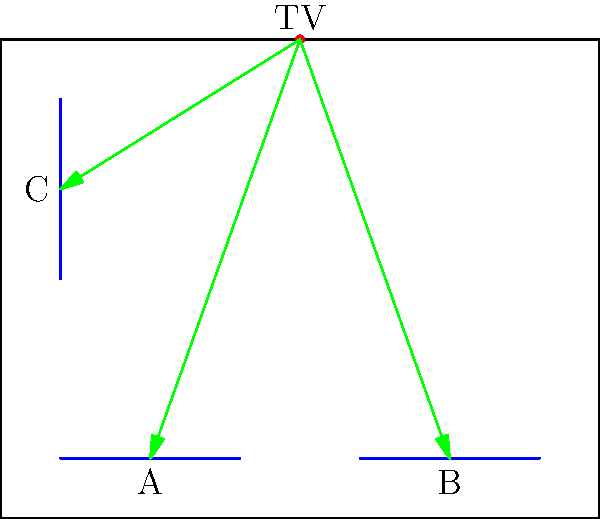For our upcoming Purdue basketball viewing party, we need to determine the optimal seating arrangement. The room layout is shown above, with the TV mounted on the wall and three couches represented by blue lines. Using vector operations, which couch position provides the best viewing angle and distance from the TV? Consider that the optimal viewing angle is 0° (directly in front of the TV) and the ideal distance is 8 feet. Assume the room dimensions are 20 feet by 16 feet. Let's approach this step-by-step:

1) First, we need to define vectors from the TV to each couch:
   $\vec{v_A} = (2.5 - 5, 1 - 8) = (-2.5, -7)$
   $\vec{v_B} = (7.5 - 5, 1 - 8) = (2.5, -7)$
   $\vec{v_C} = (1 - 5, 5.5 - 8) = (-4, -2.5)$

2) To find the viewing angle, we can use the dot product between each vector and the ideal vector (0, -1) which points straight down from the TV:
   $\cos \theta = \frac{\vec{v} \cdot (0, -1)}{|\vec{v}||(0, -1)|}$

3) For couch A:
   $\cos \theta_A = \frac{7}{\sqrt{(-2.5)^2 + (-7)^2}} \approx 0.9428$
   $\theta_A \approx 19.4°$

4) For couch B:
   $\cos \theta_B = \frac{7}{\sqrt{(2.5)^2 + (-7)^2}} \approx 0.9428$
   $\theta_B \approx 19.4°$

5) For couch C:
   $\cos \theta_C = \frac{2.5}{\sqrt{(-4)^2 + (-2.5)^2}} \approx 0.5305$
   $\theta_C \approx 58.0°$

6) Now, let's calculate the distances:
   $|v_A| = \sqrt{(-2.5)^2 + (-7)^2} \approx 7.43$ feet
   $|v_B| = \sqrt{(2.5)^2 + (-7)^2} \approx 7.43$ feet
   $|v_C| = \sqrt{(-4)^2 + (-2.5)^2} \approx 4.72$ feet

7) Comparing to the ideal distance of 8 feet:
   A and B are off by about 0.57 feet
   C is off by about 3.28 feet

8) Considering both angle and distance, couches A and B are equally optimal, with the smallest viewing angle and closest to the ideal distance.
Answer: Couches A and B (equally optimal) 